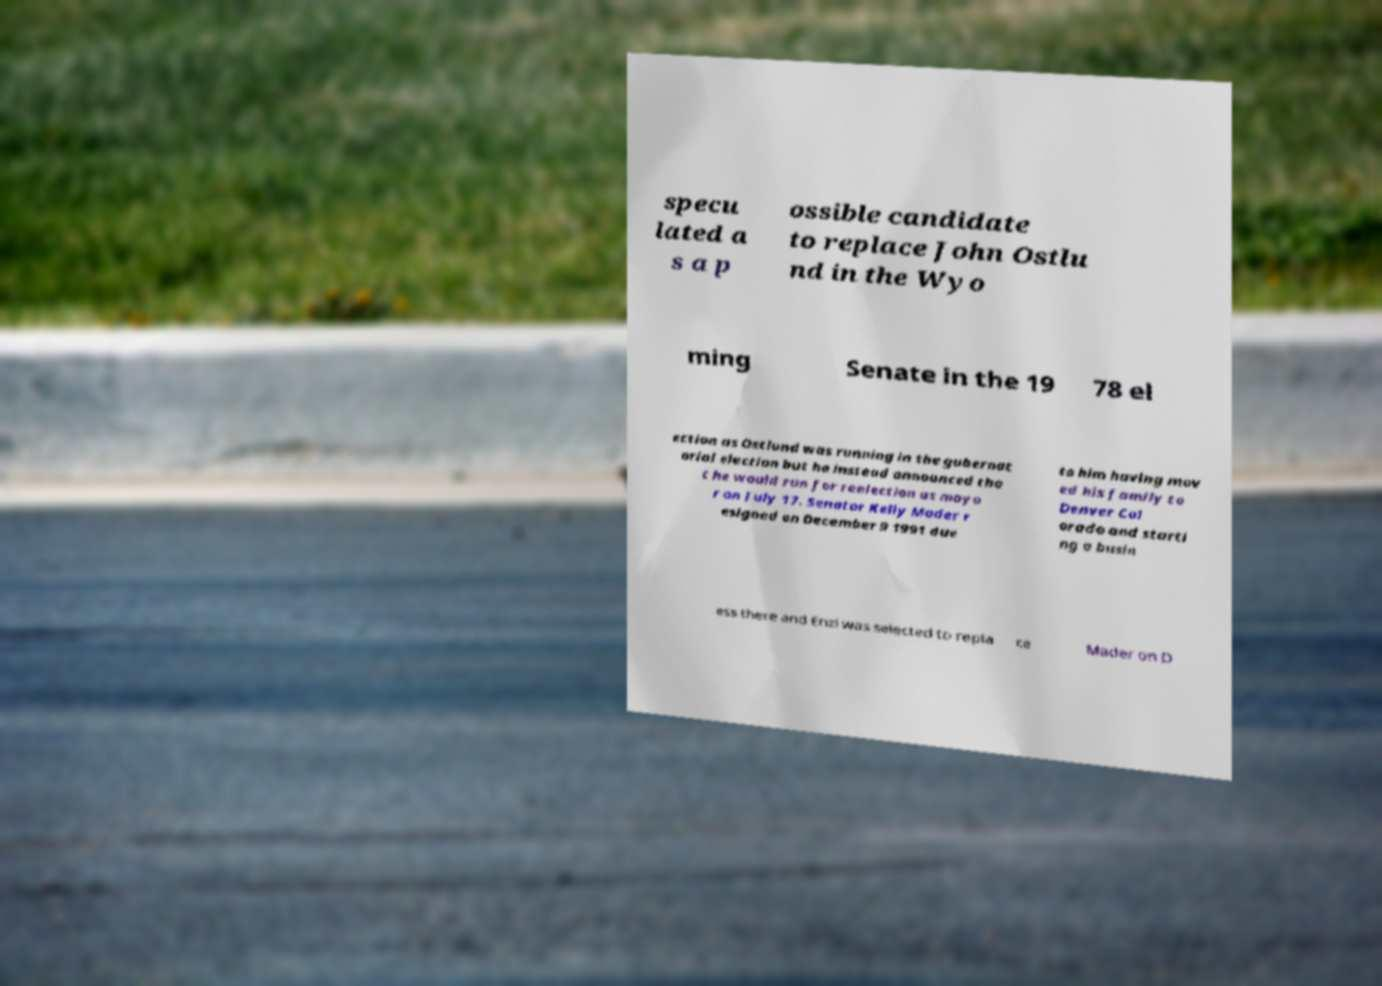What messages or text are displayed in this image? I need them in a readable, typed format. specu lated a s a p ossible candidate to replace John Ostlu nd in the Wyo ming Senate in the 19 78 el ection as Ostlund was running in the gubernat orial election but he instead announced tha t he would run for reelection as mayo r on July 17. Senator Kelly Mader r esigned on December 9 1991 due to him having mov ed his family to Denver Col orado and starti ng a busin ess there and Enzi was selected to repla ce Mader on D 